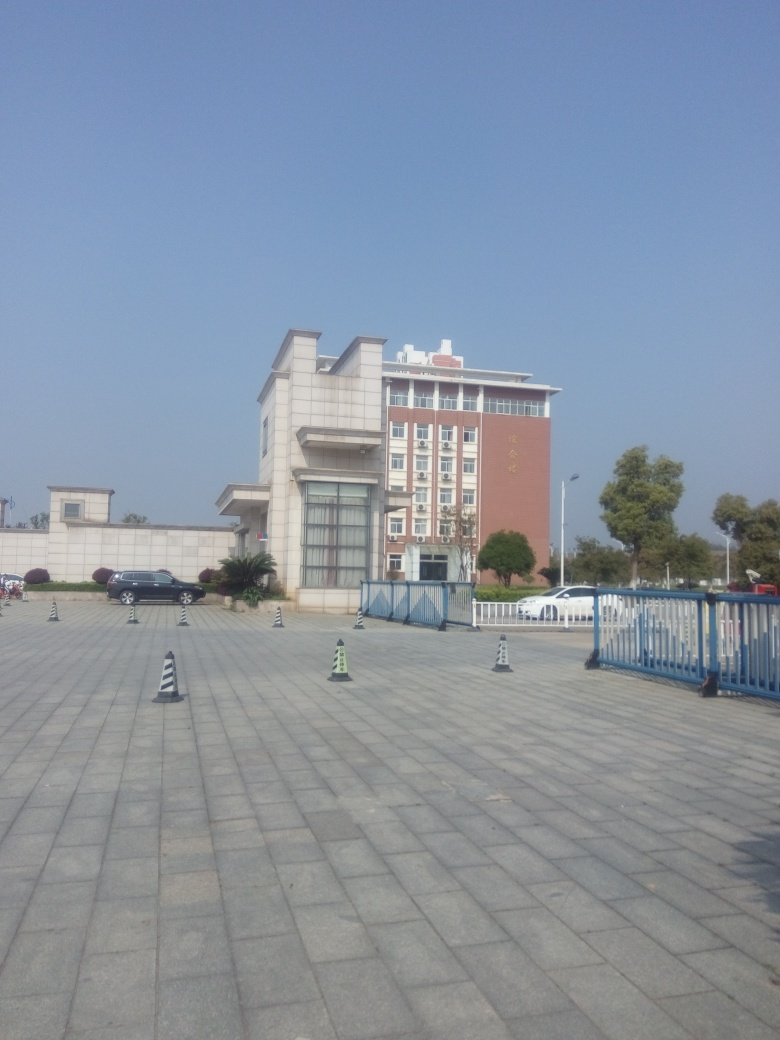Does the image highlight the focus well? The image indeed maintains a clear focus, highlighting the building and its surrounding area effectively. The large open space in the foreground, the distinct architectural features of the building, and the absence of obstructions ensure that the primary subject is presented clearly and prominently. 